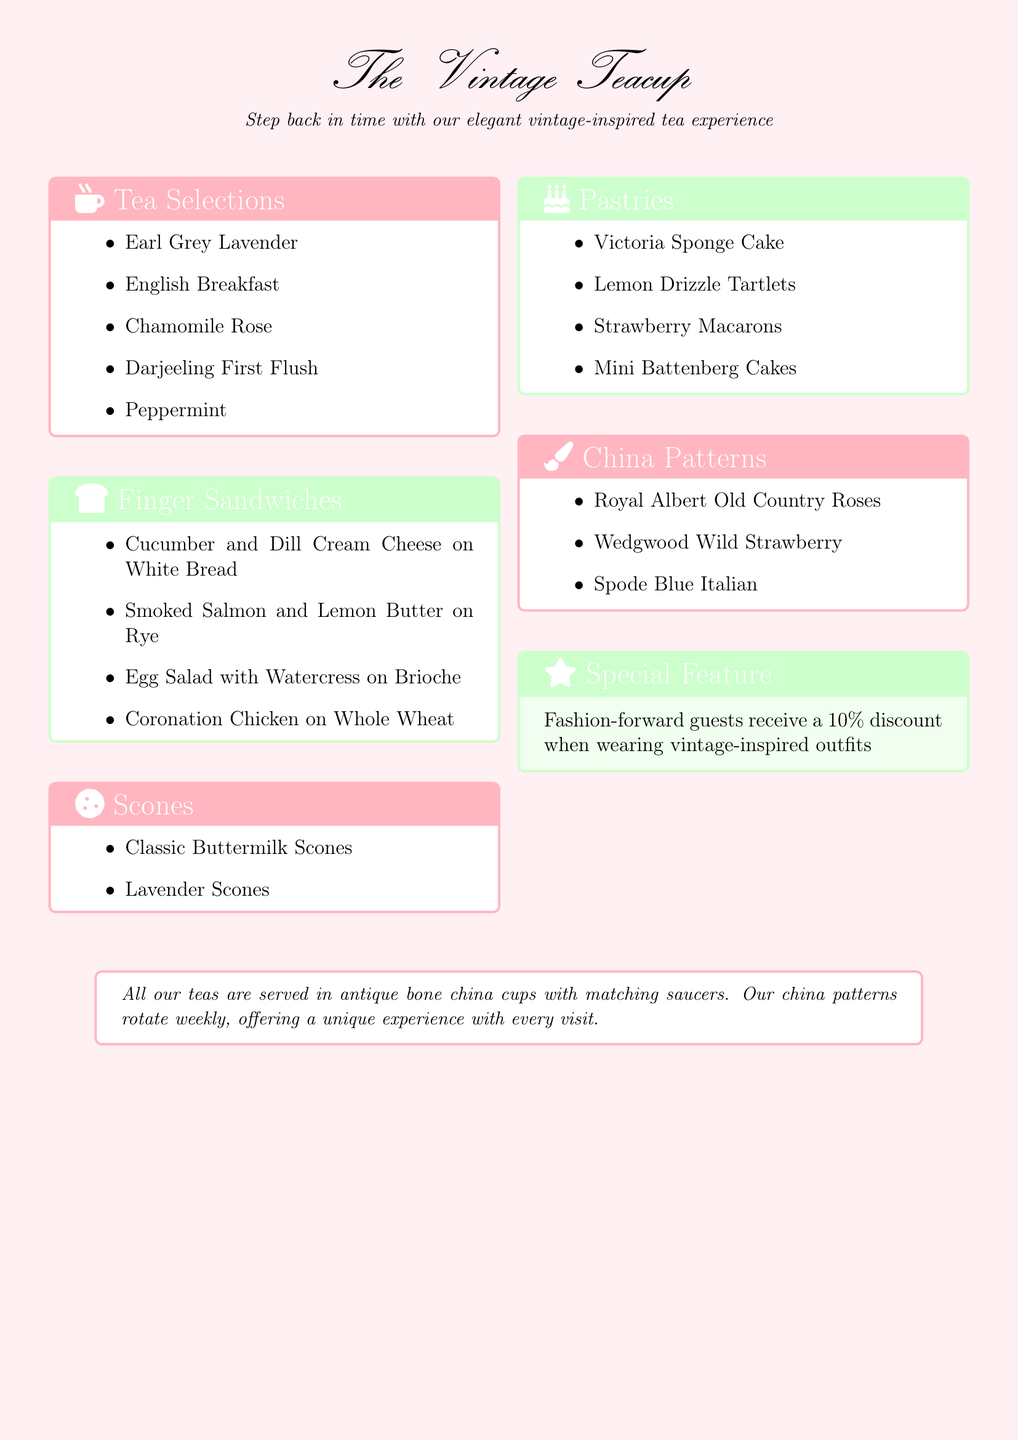what type of tea is served? The menu lists specific tea selections that customers can enjoy, including herbal and traditional types.
Answer: Earl Grey Lavender how many types of finger sandwiches are there? The document provides a list of finger sandwiches, indicating how many varieties are available.
Answer: Four what is the special feature for guests? The menu highlights a unique offer to attract guests, which is related to their clothing style.
Answer: 10% discount which china pattern is mentioned in the menu? There are specific china patterns listed in the menu, showcasing the vintage theme.
Answer: Royal Albert Old Country Roses what flavors do the scones come in? The menu specifies the flavors of scones available for guests enjoying their tea.
Answer: Classic Buttermilk Scones what kind of pastries can you find? The pastries section offers a selection of sweet treats available on the menu.
Answer: Victoria Sponge Cake which ingredient is included in the cucumber sandwich? The specific ingredients within the finger sandwich are detailed to inform guests of what to expect.
Answer: Dill Cream Cheese how are the teas served? The document describes the presentation style of teas in a charming and vintage manner.
Answer: Antique bone china cups 